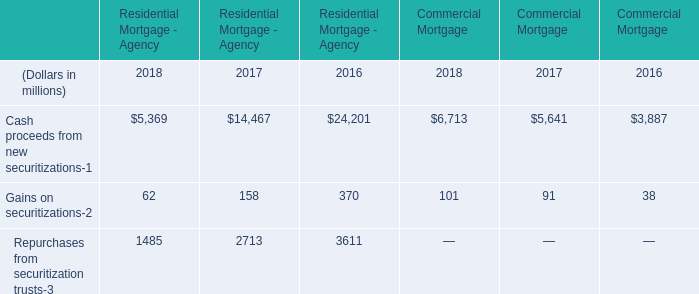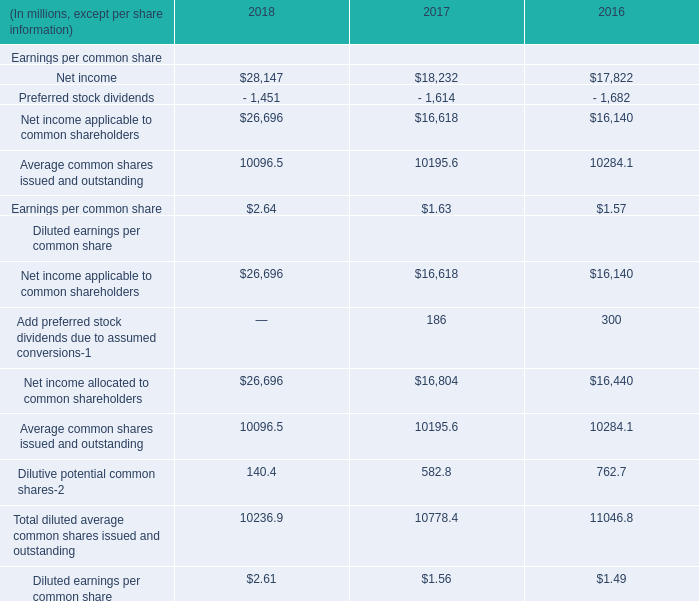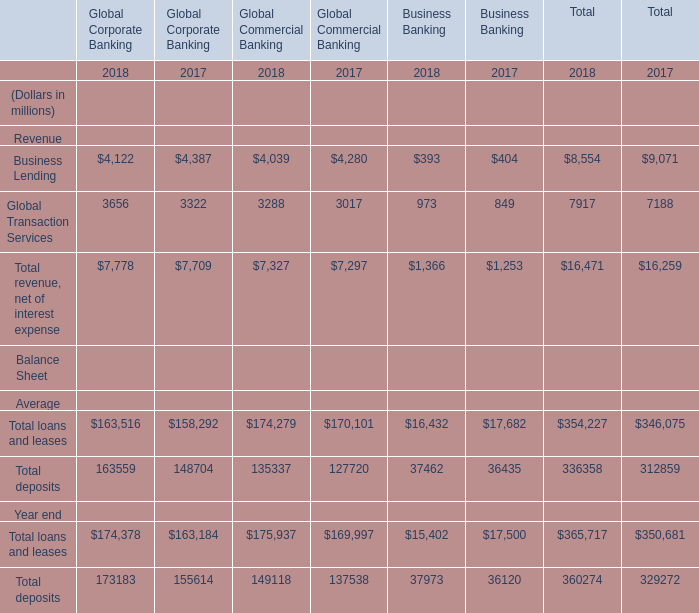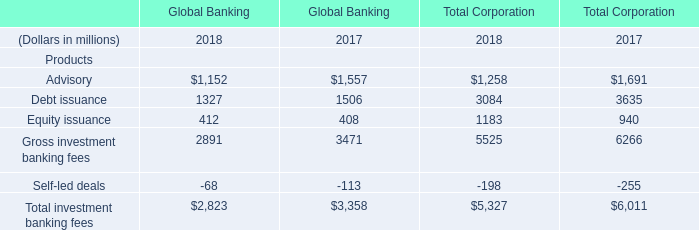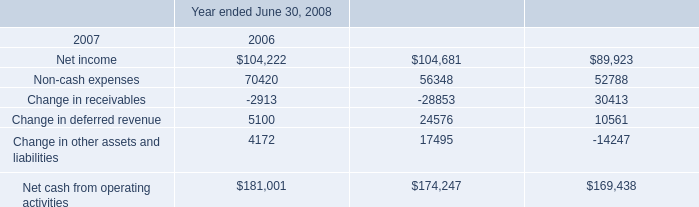in fiscal 2008 , what percentage of net cash for investment activities came from payments for acquisitions? 
Computations: (48109 / 102148)
Answer: 0.47097. 